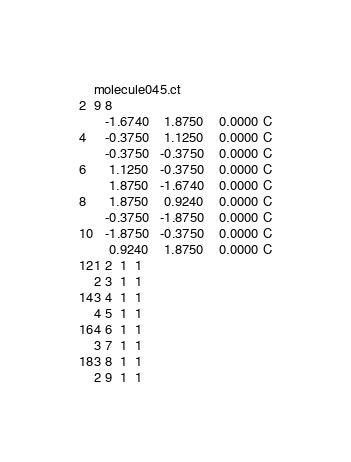Convert code to text. <code><loc_0><loc_0><loc_500><loc_500><_XML_>molecule045.ct
9 8
   -1.6740    1.8750    0.0000 C
   -0.3750    1.1250    0.0000 C
   -0.3750   -0.3750    0.0000 C
    1.1250   -0.3750    0.0000 C
    1.8750   -1.6740    0.0000 C
    1.8750    0.9240    0.0000 C
   -0.3750   -1.8750    0.0000 C
   -1.8750   -0.3750    0.0000 C
    0.9240    1.8750    0.0000 C
1 2  1  1
2 3  1  1
3 4  1  1
4 5  1  1
4 6  1  1
3 7  1  1
3 8  1  1
2 9  1  1
</code> 